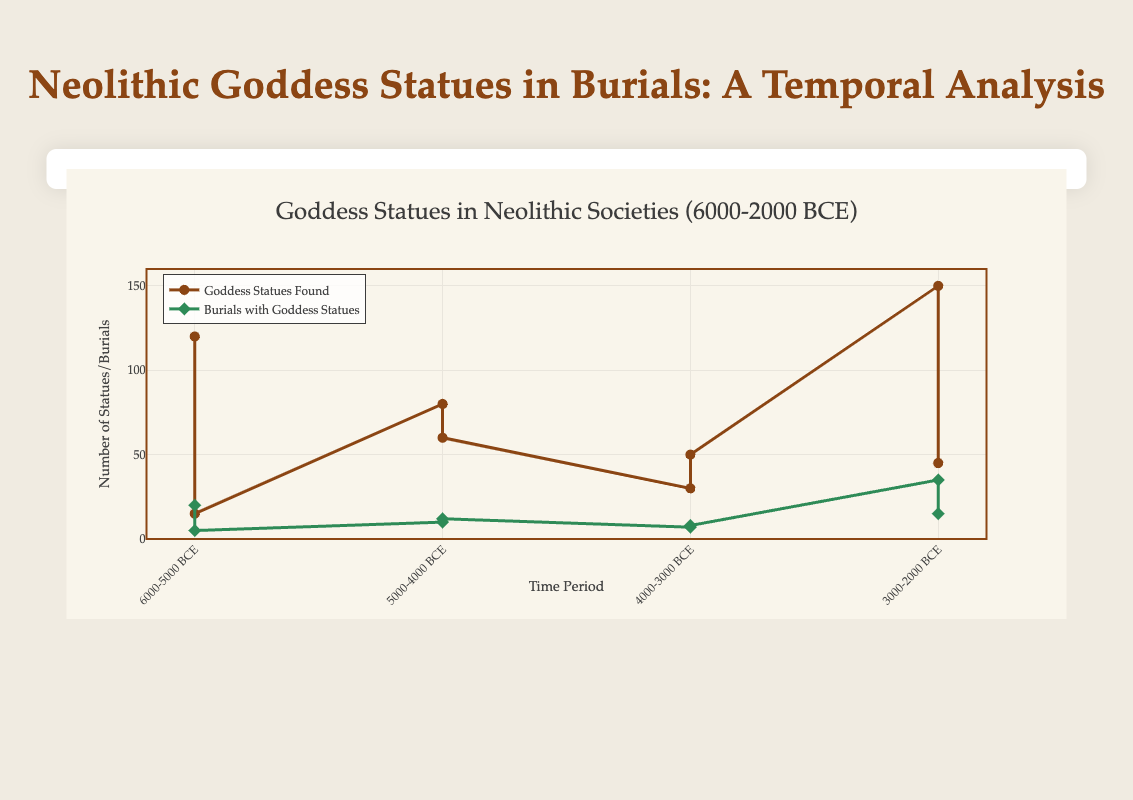What is the overall trend in the number of goddess statues found from 6000-5000 BCE to 3000-2000 BCE? To observe the trend, examine the 'Goddess Statues Found' line from 6000-5000 BCE to 3000-2000 BCE. We start with 120 statues in Anatolia at Çatalhöyük, then 15 in The Levant at Jericho, 80 in Mesopotamia at Tell Ubaid, 60 in Anatolia at Hacilar, 30 in The Levant at Byblos, 50 in the Balkans at Vinca, 150 in Mesopotamia at Ur, and finally 45 in Anatolia at Karakuyu. Notice the fluctuations, but there’s generally an increase, especially from the 4000-3000 BCE period to the 3000-2000 BCE period.
Answer: Increase overall How does the number of burials with goddess statues change from 6000-5000 BCE to 3000-2000 BCE in Mesopotamia? Focus on Mesopotamia across the given periods. In 5000-4000 BCE at Tell Ubaid, there are 10 burials. In 3000-2000 BCE at Ur, there are 35 burials. Calculate the difference: 35 - 10 = 25, showing an increase over time.
Answer: Increase by 25 Which site had the highest number of goddess statues found? Compare the 'Goddess Statues Found' values for all sites. Çatalhöyük (120), Jericho (15), Tell Ubaid (80), Hacilar (60), Byblos (30), Vinca (50), Ur (150), Karakuyu (45). The highest value is 150 at Ur.
Answer: Ur What is the total number of burials with goddess statues across all regions for the period 4000-3000 BCE? Add the burials data from Byblos (7) and Vinca (8) for the period 4000-3000 BCE: 7 + 8 = 15.
Answer: 15 How do the regions of Anatolia and The Levant compare in terms of burials with goddess statues during the 6000-5000 BCE period? Compare burials in Anatolia at Çatalhöyük (20) and The Levant at Jericho (5): 20 - 5 = 15. Anatolia has 15 more burials with goddess statues than The Levant during this period.
Answer: Anatolia has 15 more In which region did the number of goddess statues found see a significant increase from one time period to the next, and by how much? Compare the increases across regions and periods: In Mesopotamia, Tell Ubaid (80) to Ur (150), the increase is 150 - 80 = 70, which is the largest change.
Answer: Mesopotamia, by 70 Which time period saw the highest number of burials with goddess statues across all regions? Sum up burials for each period: 
- 6000-5000 BCE: 20 (Çatalhöyük) + 5 (Jericho) = 25 
- 5000-4000 BCE: 10 (Tell Ubaid) + 12 (Hacilar) = 22 
- 4000-3000 BCE: 7 (Byblos) + 8 (Vinca) = 15 
- 3000-2000 BCE: 35 (Ur) + 15 (Karakuyu) = 50. 
The highest number is 50 in 3000-2000 BCE.
Answer: 3000-2000 BCE 